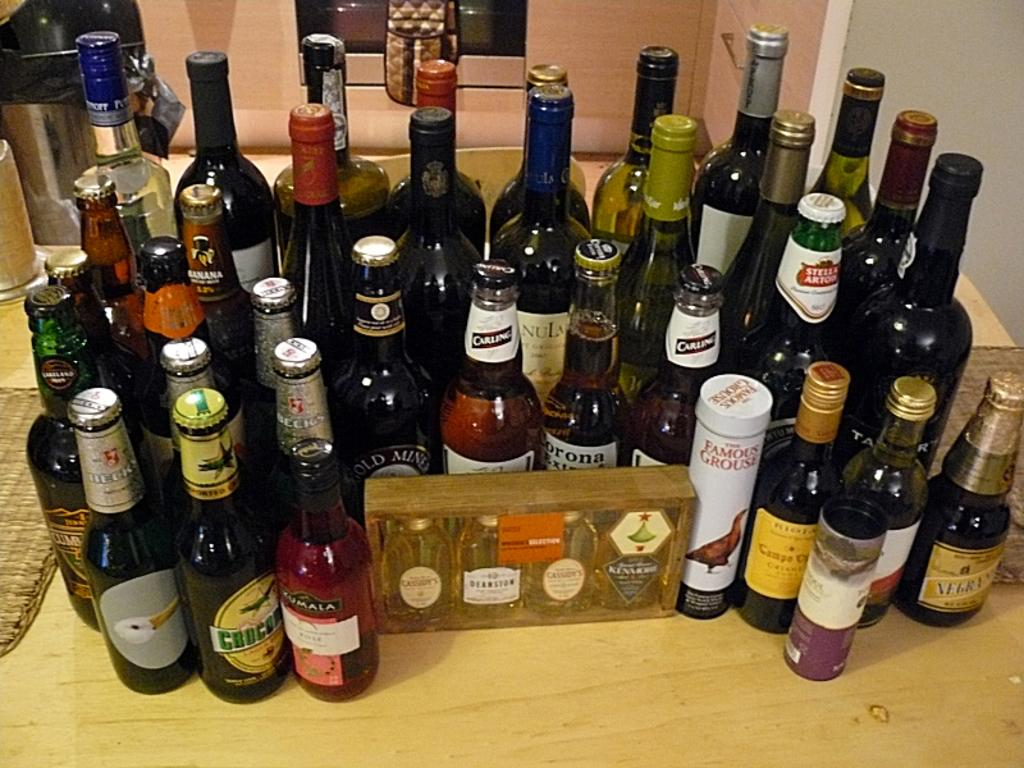Provide a one-sentence caption for the provided image. A bunch of beer and wine bottles on a table with a Beck's beer bottle on the far left. 